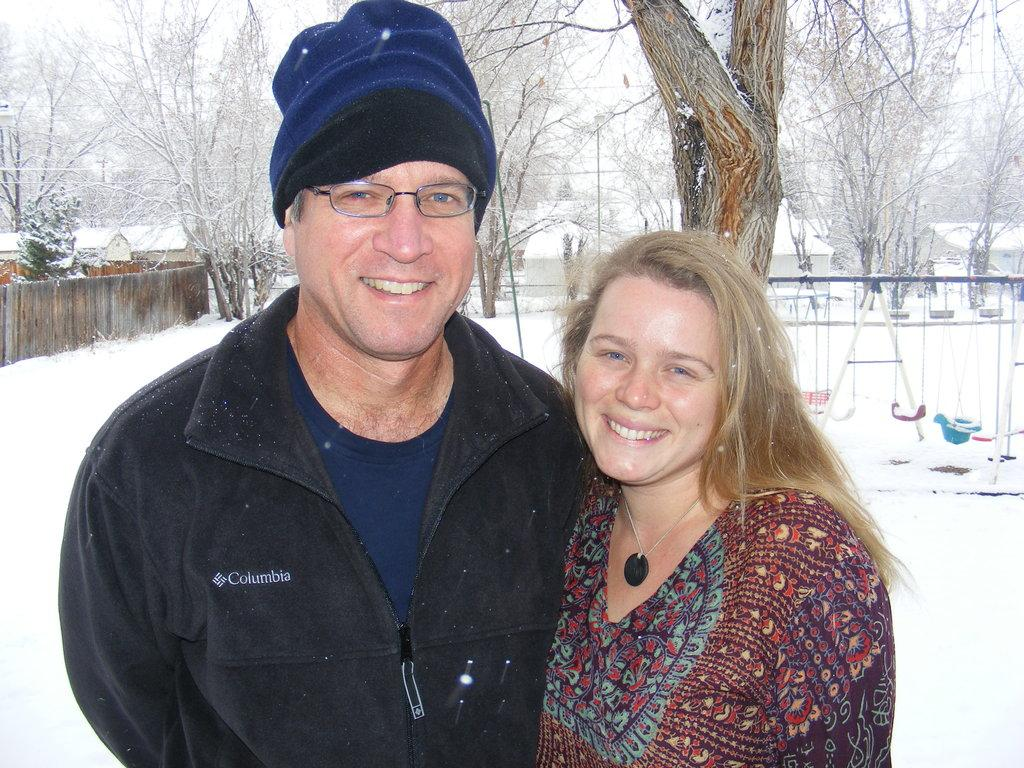Who are the people in the image? There is a man and a woman in the image. What is the background of the image like? There is snow and trees in the background of the image. Can you see the woman's brother in the image? There is no mention of a brother in the image, so we cannot determine if the woman's brother is present. What type of mist is visible in the image? There is no mention of mist in the image, so we cannot determine if any mist is present. 